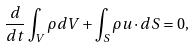<formula> <loc_0><loc_0><loc_500><loc_500>\frac { d } { d t } \int _ { V } \rho d V + \int _ { S } \rho { u } \cdot d { S } = 0 ,</formula> 